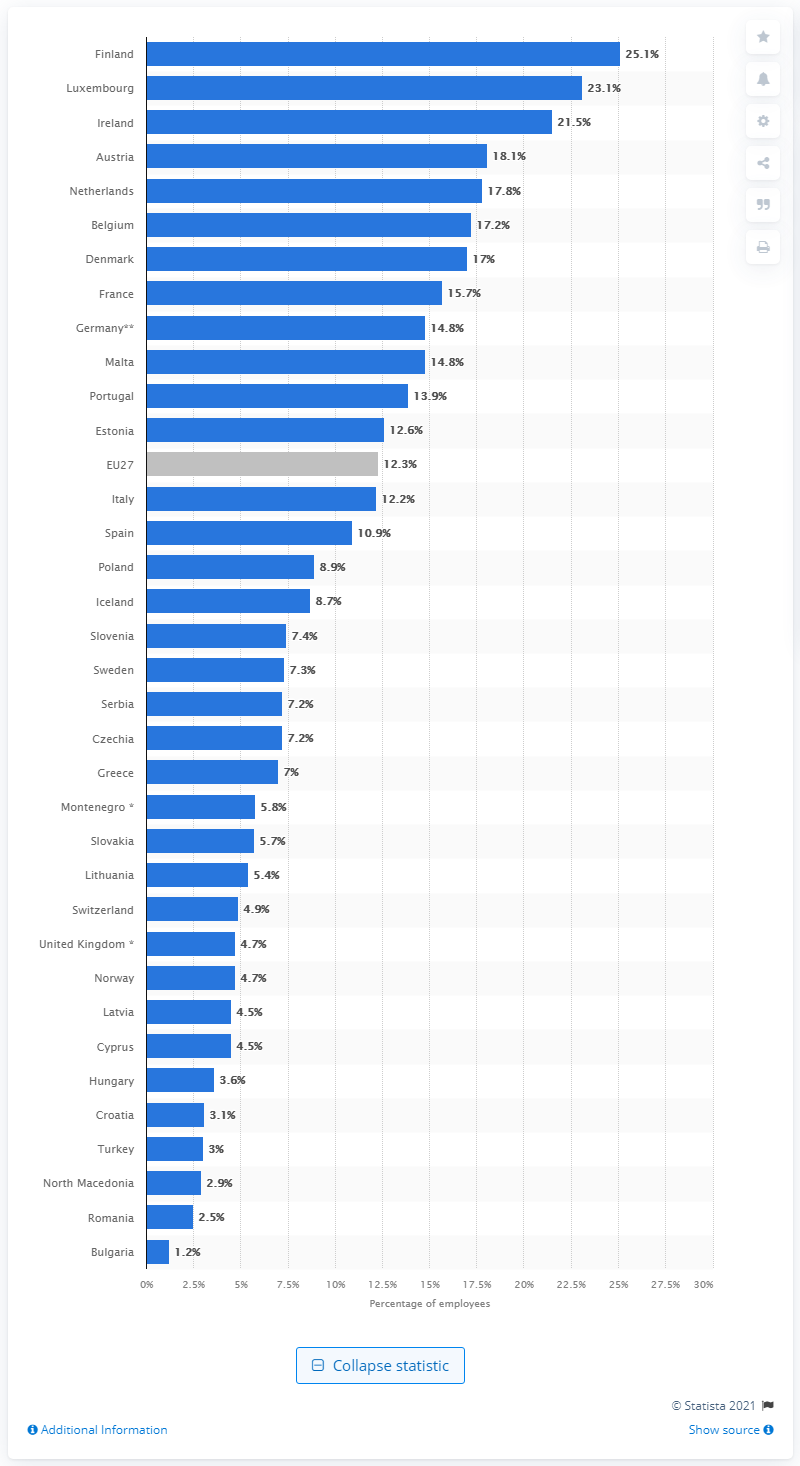Point out several critical features in this image. Bulgaria has the lowest percentage of people working from home among European countries. The average number of people working from home in the European Union is 12.3. 